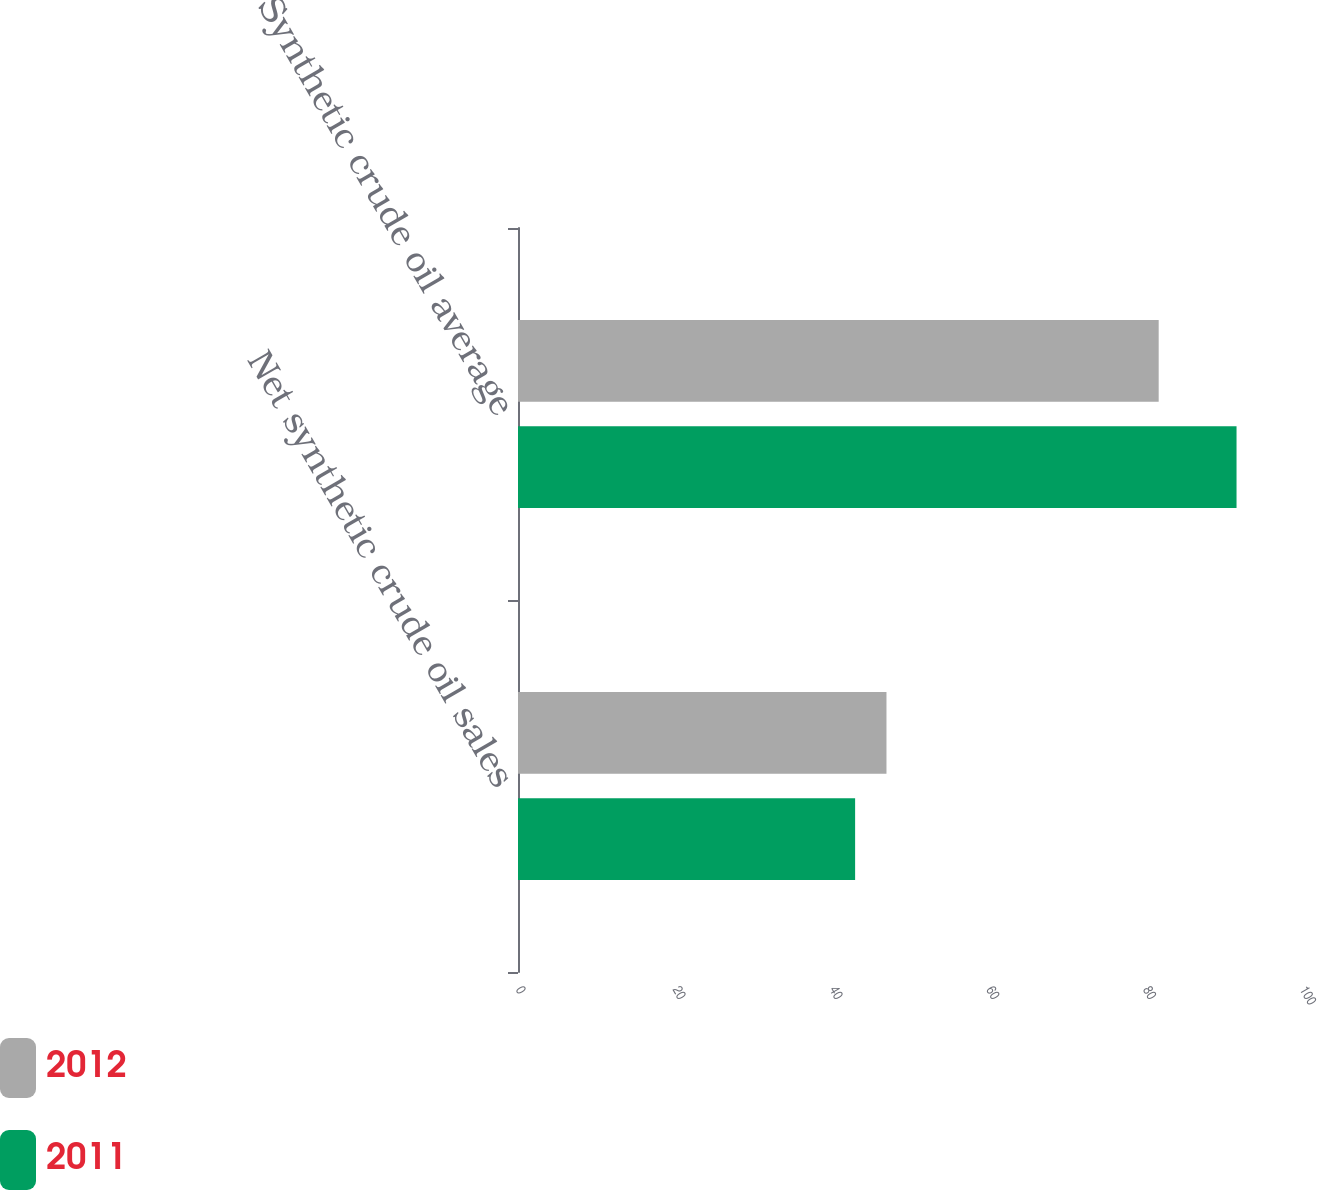Convert chart to OTSL. <chart><loc_0><loc_0><loc_500><loc_500><stacked_bar_chart><ecel><fcel>Net synthetic crude oil sales<fcel>Synthetic crude oil average<nl><fcel>2012<fcel>47<fcel>81.72<nl><fcel>2011<fcel>43<fcel>91.65<nl></chart> 